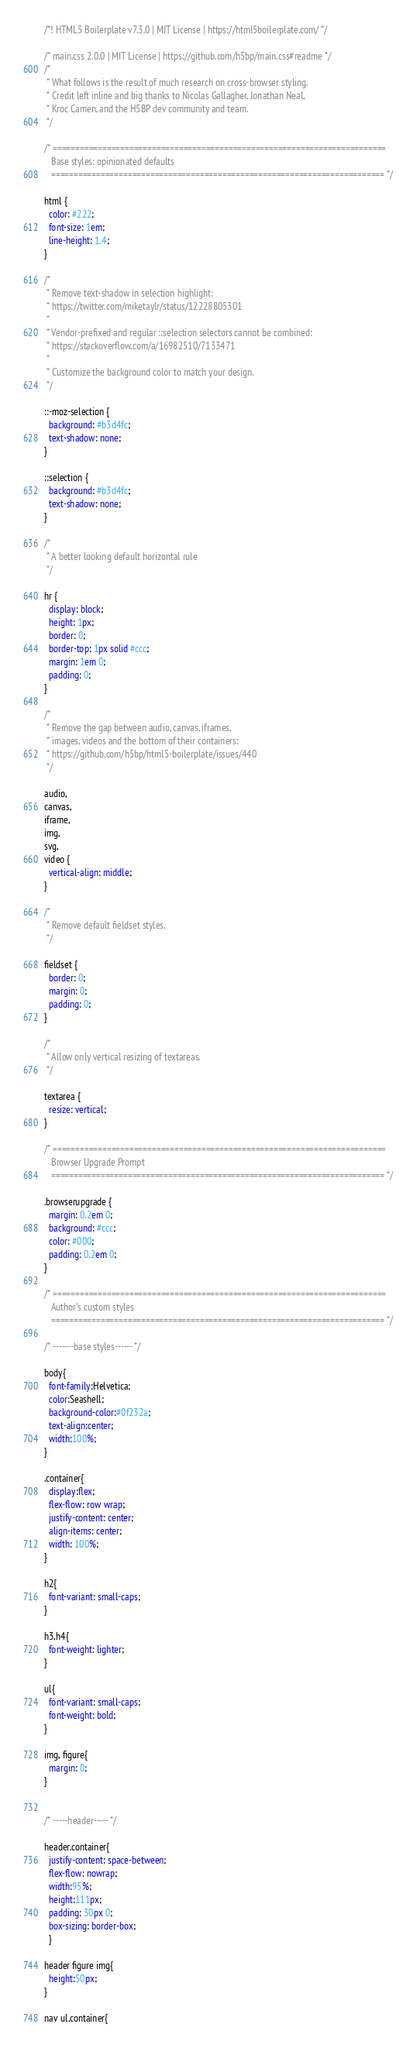<code> <loc_0><loc_0><loc_500><loc_500><_CSS_>/*! HTML5 Boilerplate v7.3.0 | MIT License | https://html5boilerplate.com/ */

/* main.css 2.0.0 | MIT License | https://github.com/h5bp/main.css#readme */
/*
 * What follows is the result of much research on cross-browser styling.
 * Credit left inline and big thanks to Nicolas Gallagher, Jonathan Neal,
 * Kroc Camen, and the H5BP dev community and team.
 */

/* ==========================================================================
   Base styles: opinionated defaults
   ========================================================================== */

html {
  color: #222;
  font-size: 1em;
  line-height: 1.4;
}

/*
 * Remove text-shadow in selection highlight:
 * https://twitter.com/miketaylr/status/12228805301
 *
 * Vendor-prefixed and regular ::selection selectors cannot be combined:
 * https://stackoverflow.com/a/16982510/7133471
 *
 * Customize the background color to match your design.
 */

::-moz-selection {
  background: #b3d4fc;
  text-shadow: none;
}

::selection {
  background: #b3d4fc;
  text-shadow: none;
}

/*
 * A better looking default horizontal rule
 */

hr {
  display: block;
  height: 1px;
  border: 0;
  border-top: 1px solid #ccc;
  margin: 1em 0;
  padding: 0;
}

/*
 * Remove the gap between audio, canvas, iframes,
 * images, videos and the bottom of their containers:
 * https://github.com/h5bp/html5-boilerplate/issues/440
 */

audio,
canvas,
iframe,
img,
svg,
video {
  vertical-align: middle;
}

/*
 * Remove default fieldset styles.
 */

fieldset {
  border: 0;
  margin: 0;
  padding: 0;
}

/*
 * Allow only vertical resizing of textareas.
 */

textarea {
  resize: vertical;
}

/* ==========================================================================
   Browser Upgrade Prompt
   ========================================================================== */

.browserupgrade {
  margin: 0.2em 0;
  background: #ccc;
  color: #000;
  padding: 0.2em 0;
}

/* ==========================================================================
   Author's custom styles
   ========================================================================== */

/* -------base styles------ */

body{
  font-family:Helvetica;
  color:Seashell;
  background-color:#0f232a;
  text-align:center;
  width:100%;
}

.container{
  display:flex;
  flex-flow: row wrap;
  justify-content: center;
  align-items: center;
  width: 100%;
}

h2{
  font-variant: small-caps;
}

h3,h4{
  font-weight: lighter;
}

ul{
  font-variant: small-caps;
  font-weight: bold;
}

img, figure{
  margin: 0;
}


/* -----header----- */

header.container{
  justify-content: space-between;
  flex-flow: nowrap;
  width:95%;
  height:111px;
  padding: 30px 0;
  box-sizing: border-box;
  }

header figure img{
  height:50px;
}

nav ul.container{</code> 